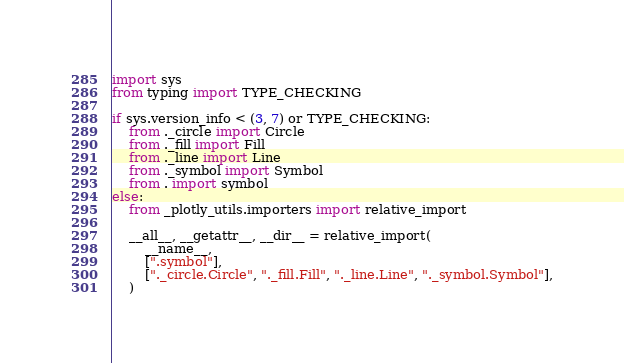Convert code to text. <code><loc_0><loc_0><loc_500><loc_500><_Python_>import sys
from typing import TYPE_CHECKING

if sys.version_info < (3, 7) or TYPE_CHECKING:
    from ._circle import Circle
    from ._fill import Fill
    from ._line import Line
    from ._symbol import Symbol
    from . import symbol
else:
    from _plotly_utils.importers import relative_import

    __all__, __getattr__, __dir__ = relative_import(
        __name__,
        [".symbol"],
        ["._circle.Circle", "._fill.Fill", "._line.Line", "._symbol.Symbol"],
    )
</code> 